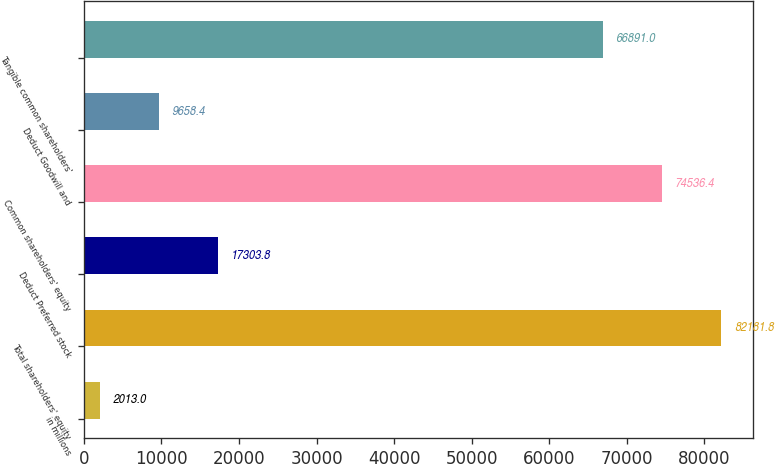Convert chart. <chart><loc_0><loc_0><loc_500><loc_500><bar_chart><fcel>in millions<fcel>Total shareholders' equity<fcel>Deduct Preferred stock<fcel>Common shareholders' equity<fcel>Deduct Goodwill and<fcel>Tangible common shareholders'<nl><fcel>2013<fcel>82181.8<fcel>17303.8<fcel>74536.4<fcel>9658.4<fcel>66891<nl></chart> 